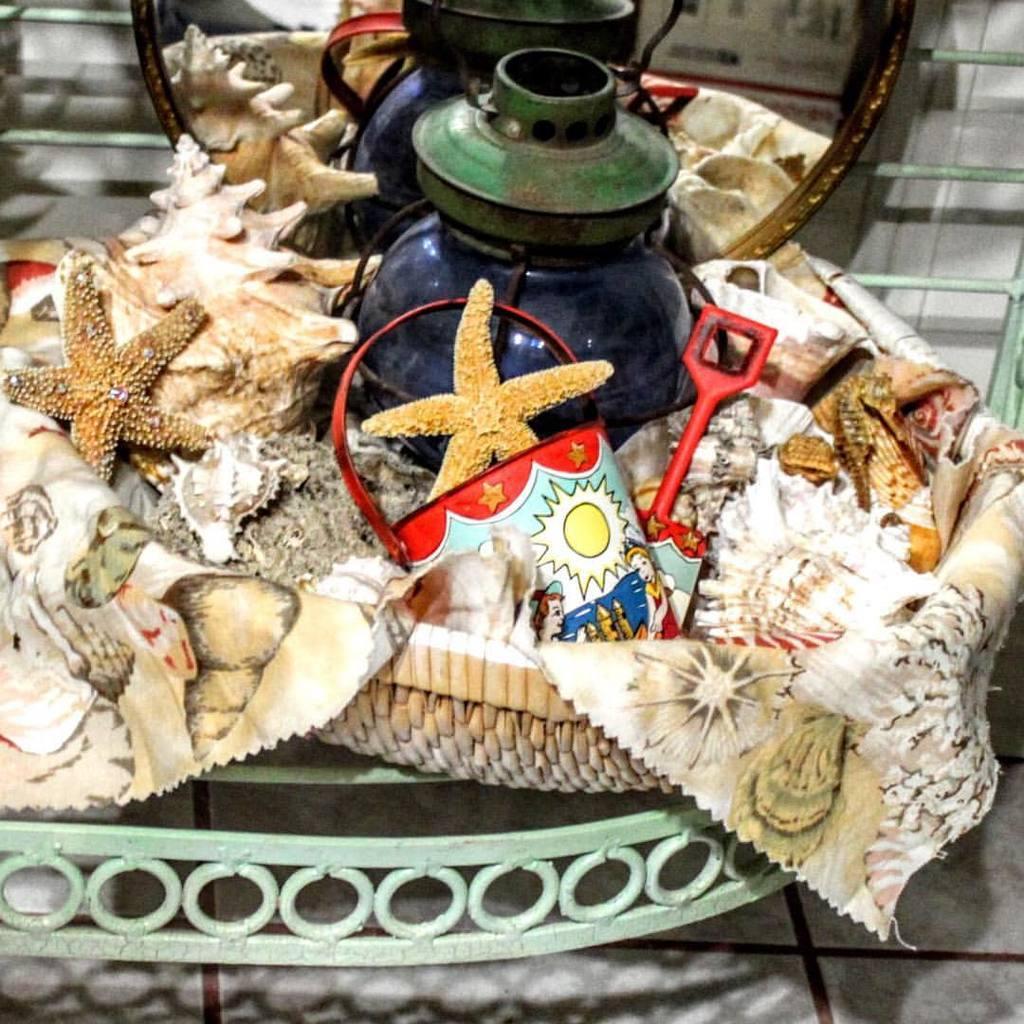Can you describe this image briefly? In this image we can see a tire, lamp, bucket, cloth and some objects in a basket which is placed on a metal frame. On the backside we can see some metal poles and a wall. 